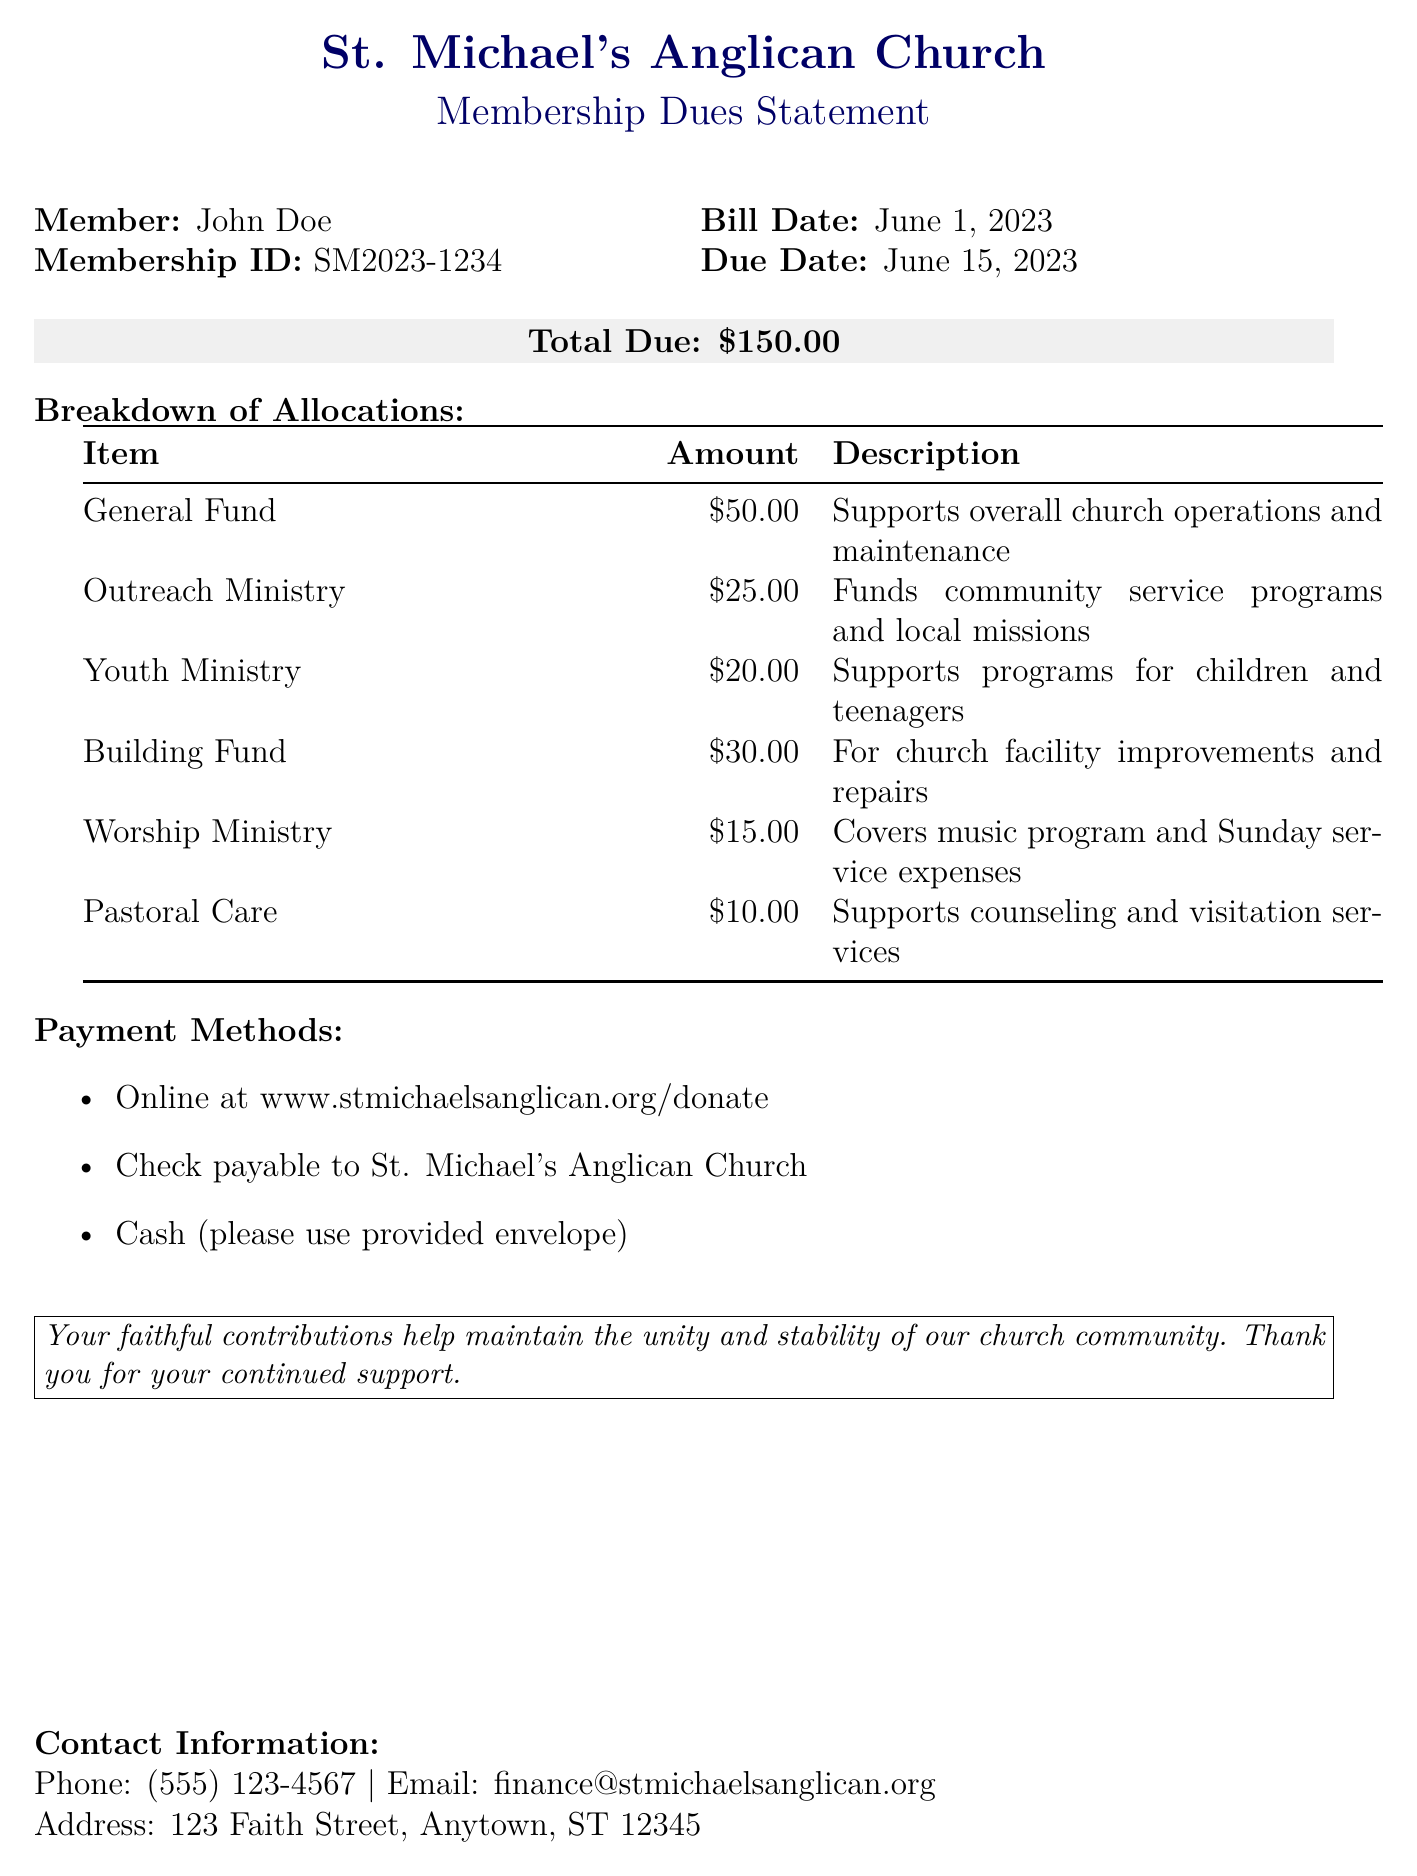what is the total due amount? The total amount due is prominently displayed in the document.
Answer: $150.00 who is the member listed in the document? The member's name is provided at the top of the bill.
Answer: John Doe what is the due date for the payment? The due date is specified for the payment of the dues.
Answer: June 15, 2023 how much is allocated to the Outreach Ministry? The breakdown of allocations includes the amount directed to the Outreach Ministry.
Answer: $25.00 what is the purpose of the Building Fund? A description of the Building Fund is listed under its allocation details.
Answer: For church facility improvements and repairs which payment method is not mentioned in the document? The document lists various payment methods, implying which might be excluded.
Answer: Mobile payment what percentage of the total due is allocated to the General Fund? This can be calculated using the amounts given in the breakdown section.
Answer: 33.33% what is the contact email provided in the document? The contact information includes an email address for inquiries.
Answer: finance@stmichaelsanglican.org what ministry receives the lowest allocation? The allocations table lists the amounts per ministry, indicating which is lowest.
Answer: Pastoral Care 